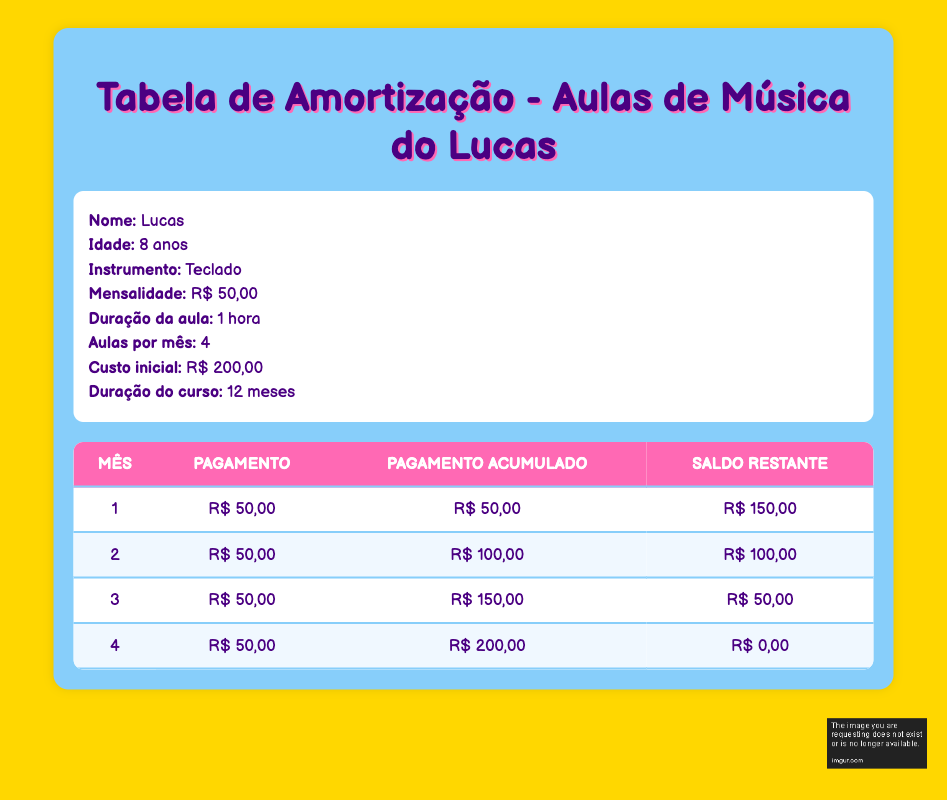What is the initial cost for Lucas's music classes? The initial cost is provided directly in the table under "Custo inicial". The value is R$ 200,00.
Answer: R$ 200,00 How much is Lucas's monthly fee for music classes? The monthly fee is listed in the table and is R$ 50,00.
Answer: R$ 50,00 What is the cumulative payment at the end of month 3? The cumulative payment column shows the value at the end of month 3 as R$ 150,00.
Answer: R$ 150,00 Is the remaining balance at the end of month 2 greater than R$ 50,00? The remaining balance at the end of month 2 is R$ 100,00, which is indeed greater than R$ 50,00.
Answer: Yes How many total classes does Lucas attend in the first 4 months? Each month has 4 classes, so in 4 months, the total is 4 classes/month multiplied by 4 months, which equals 16 classes.
Answer: 16 classes What was the total amount paid by the end of month 4? By the end of month 4, the cumulative payment reaches R$ 200,00, which matches the initial cost.
Answer: R$ 200,00 What is the total remaining balance after the payment in month 1? After the payment in month 1 of R$ 50,00, the remaining balance is R$ 150,00, which can be found in the corresponding column.
Answer: R$ 150,00 How much did Lucas pay in total during the first half of the amortization schedule (first 2 months)? The payment for the first 2 months is R$ 50,00 each, so total payment for 2 months is 50 + 50 = R$ 100,00.
Answer: R$ 100,00 By how much does the remaining balance decrease from month 3 to month 4? The remaining balance decreases from R$ 50,00 in month 3 to R$ 0,00 in month 4, giving a change of 50 - 0 = R$ 50,00.
Answer: R$ 50,00 